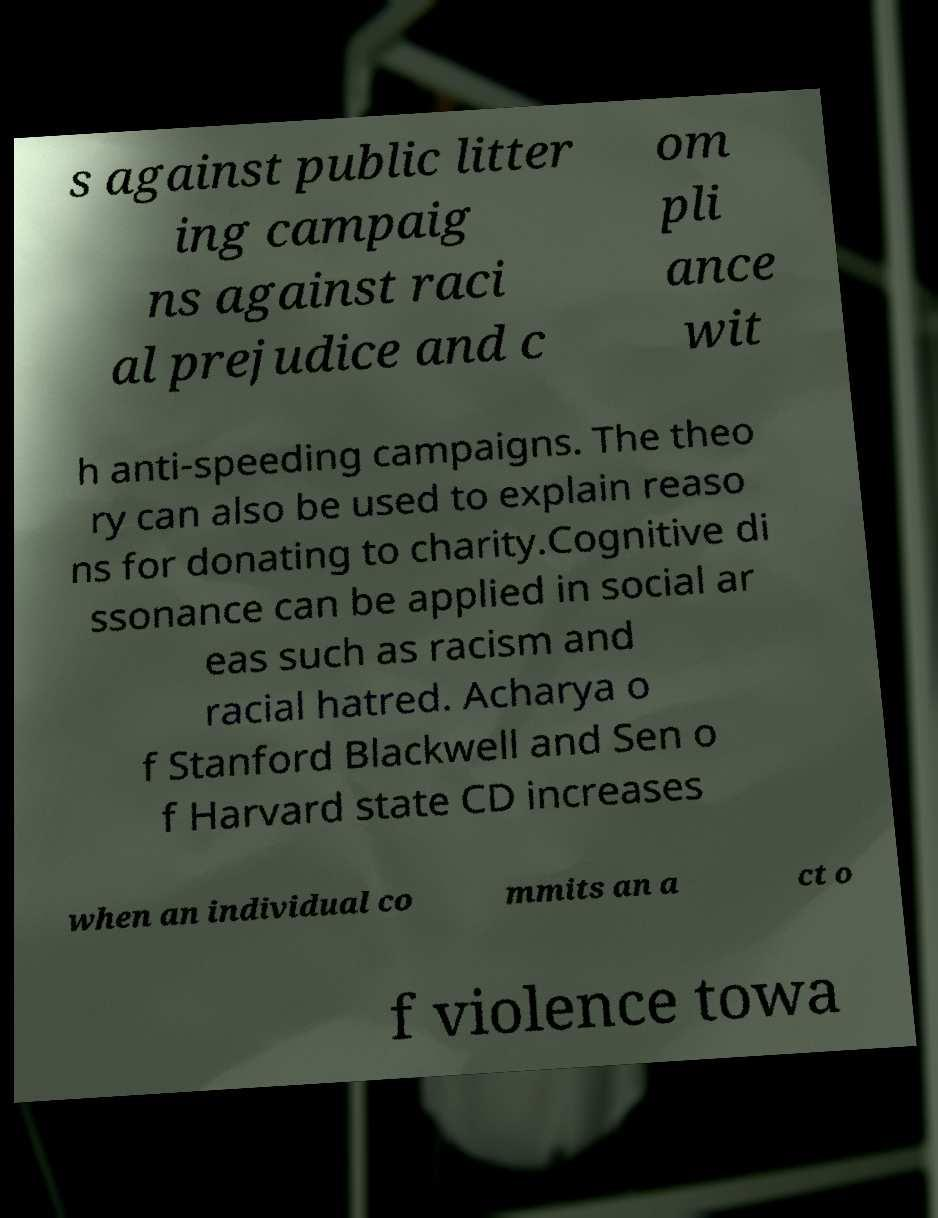Can you read and provide the text displayed in the image?This photo seems to have some interesting text. Can you extract and type it out for me? s against public litter ing campaig ns against raci al prejudice and c om pli ance wit h anti-speeding campaigns. The theo ry can also be used to explain reaso ns for donating to charity.Cognitive di ssonance can be applied in social ar eas such as racism and racial hatred. Acharya o f Stanford Blackwell and Sen o f Harvard state CD increases when an individual co mmits an a ct o f violence towa 